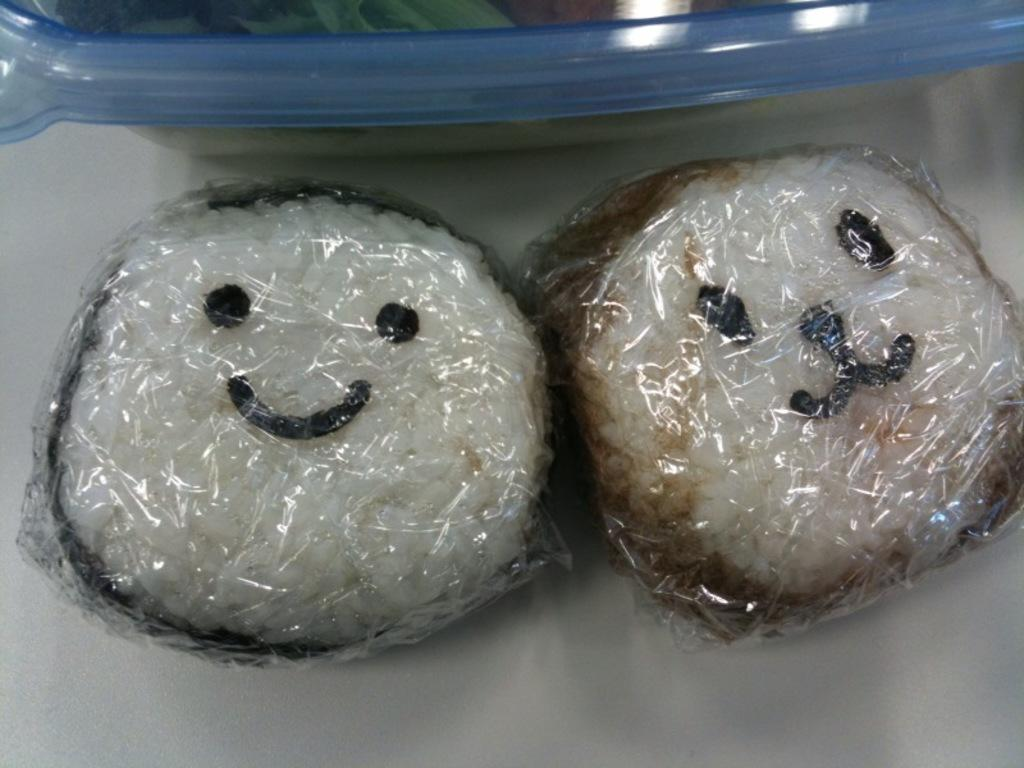What types of food items can be seen in the image? The image contains food items, but the specific types are not mentioned. Where are the food items located? The food items are placed on a surface. What type of form is the food arranged in on the surface? The facts do not mention any specific form or arrangement of the food items on the surface. What is the food's opinion about hate in the image? The food items in the image are inanimate objects and therefore cannot have opinions about hate. 